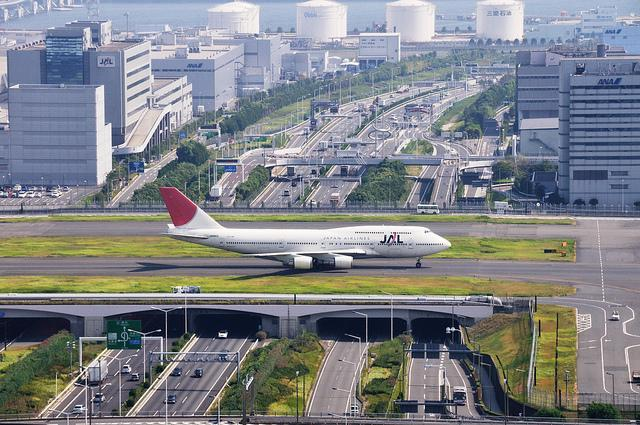What vehicle is the largest shown? airplane 